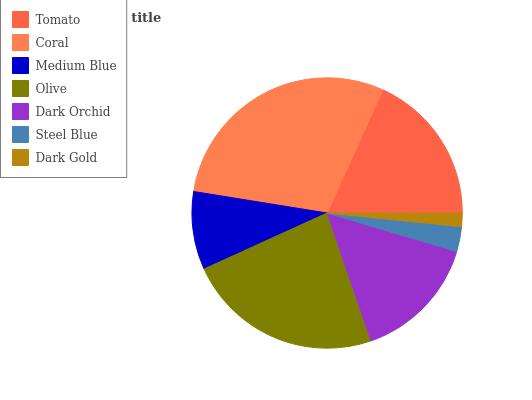Is Dark Gold the minimum?
Answer yes or no. Yes. Is Coral the maximum?
Answer yes or no. Yes. Is Medium Blue the minimum?
Answer yes or no. No. Is Medium Blue the maximum?
Answer yes or no. No. Is Coral greater than Medium Blue?
Answer yes or no. Yes. Is Medium Blue less than Coral?
Answer yes or no. Yes. Is Medium Blue greater than Coral?
Answer yes or no. No. Is Coral less than Medium Blue?
Answer yes or no. No. Is Dark Orchid the high median?
Answer yes or no. Yes. Is Dark Orchid the low median?
Answer yes or no. Yes. Is Medium Blue the high median?
Answer yes or no. No. Is Dark Gold the low median?
Answer yes or no. No. 